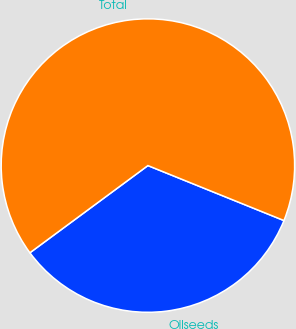Convert chart. <chart><loc_0><loc_0><loc_500><loc_500><pie_chart><fcel>Oilseeds<fcel>Total<nl><fcel>33.76%<fcel>66.24%<nl></chart> 